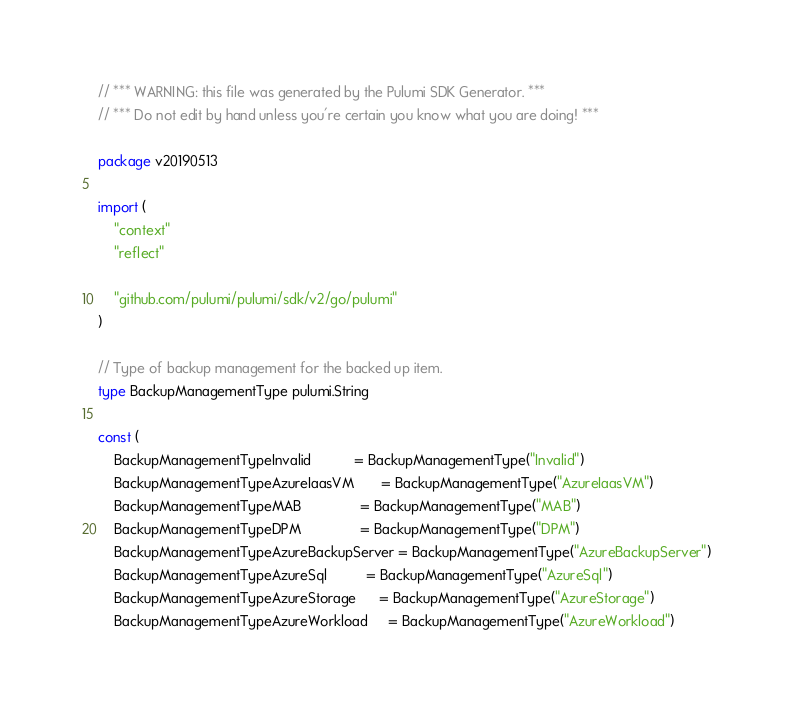Convert code to text. <code><loc_0><loc_0><loc_500><loc_500><_Go_>// *** WARNING: this file was generated by the Pulumi SDK Generator. ***
// *** Do not edit by hand unless you're certain you know what you are doing! ***

package v20190513

import (
	"context"
	"reflect"

	"github.com/pulumi/pulumi/sdk/v2/go/pulumi"
)

// Type of backup management for the backed up item.
type BackupManagementType pulumi.String

const (
	BackupManagementTypeInvalid           = BackupManagementType("Invalid")
	BackupManagementTypeAzureIaasVM       = BackupManagementType("AzureIaasVM")
	BackupManagementTypeMAB               = BackupManagementType("MAB")
	BackupManagementTypeDPM               = BackupManagementType("DPM")
	BackupManagementTypeAzureBackupServer = BackupManagementType("AzureBackupServer")
	BackupManagementTypeAzureSql          = BackupManagementType("AzureSql")
	BackupManagementTypeAzureStorage      = BackupManagementType("AzureStorage")
	BackupManagementTypeAzureWorkload     = BackupManagementType("AzureWorkload")</code> 